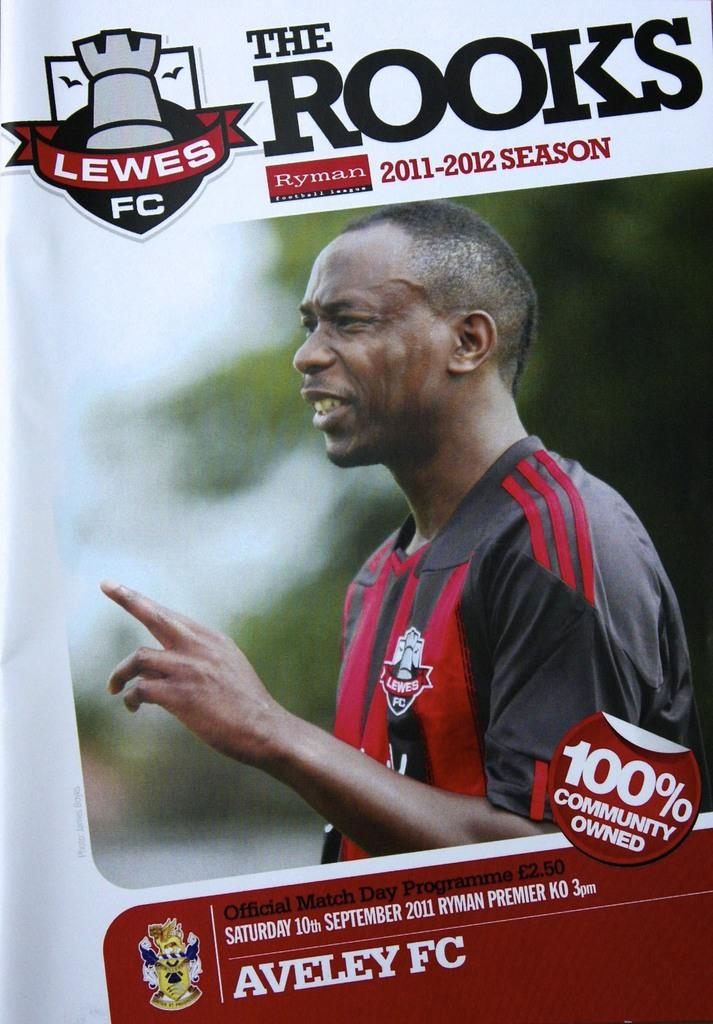What type of image is shown in the picture? The image appears to be a poster. Who or what is depicted on the poster? There is a man depicted on the poster. Are there any words or phrases on the poster? Yes, there is text present on the poster. What type of mask is the man wearing in the image? There is no mask visible on the man in the image. Can you see any dinosaurs in the image? No, there are no dinosaurs present in the image. 